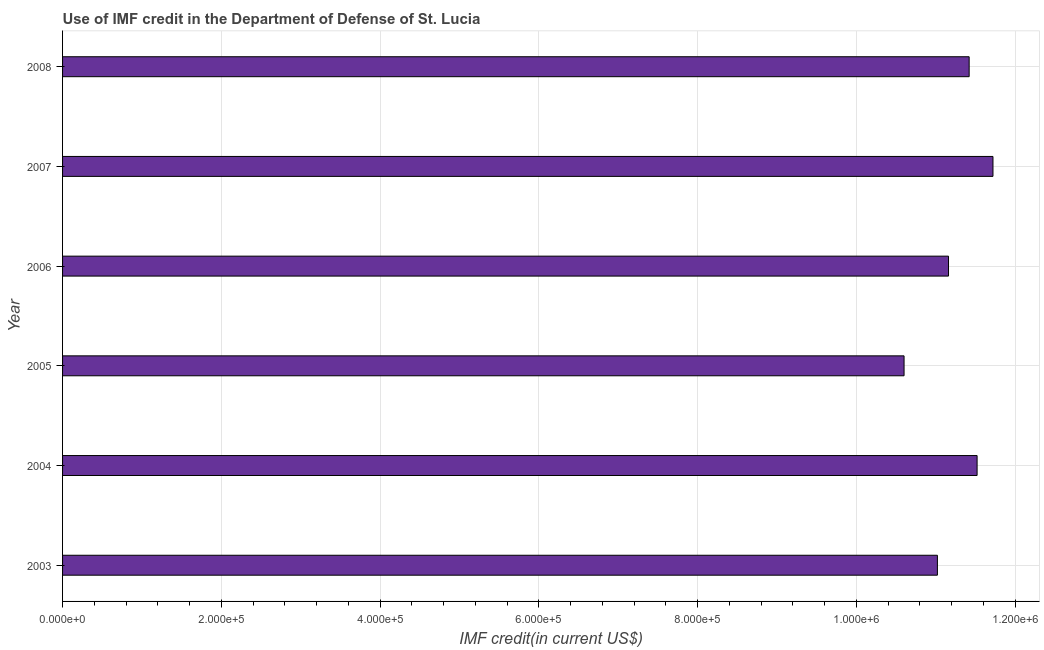What is the title of the graph?
Your response must be concise. Use of IMF credit in the Department of Defense of St. Lucia. What is the label or title of the X-axis?
Keep it short and to the point. IMF credit(in current US$). What is the use of imf credit in dod in 2008?
Offer a terse response. 1.14e+06. Across all years, what is the maximum use of imf credit in dod?
Offer a terse response. 1.17e+06. Across all years, what is the minimum use of imf credit in dod?
Your answer should be compact. 1.06e+06. In which year was the use of imf credit in dod minimum?
Keep it short and to the point. 2005. What is the sum of the use of imf credit in dod?
Keep it short and to the point. 6.74e+06. What is the difference between the use of imf credit in dod in 2003 and 2006?
Ensure brevity in your answer.  -1.40e+04. What is the average use of imf credit in dod per year?
Offer a very short reply. 1.12e+06. What is the median use of imf credit in dod?
Give a very brief answer. 1.13e+06. Do a majority of the years between 2006 and 2005 (inclusive) have use of imf credit in dod greater than 520000 US$?
Ensure brevity in your answer.  No. Is the use of imf credit in dod in 2003 less than that in 2004?
Provide a succinct answer. Yes. What is the difference between the highest and the second highest use of imf credit in dod?
Ensure brevity in your answer.  2.00e+04. Is the sum of the use of imf credit in dod in 2003 and 2007 greater than the maximum use of imf credit in dod across all years?
Provide a succinct answer. Yes. What is the difference between the highest and the lowest use of imf credit in dod?
Your answer should be very brief. 1.12e+05. What is the IMF credit(in current US$) in 2003?
Provide a succinct answer. 1.10e+06. What is the IMF credit(in current US$) in 2004?
Provide a short and direct response. 1.15e+06. What is the IMF credit(in current US$) in 2005?
Ensure brevity in your answer.  1.06e+06. What is the IMF credit(in current US$) in 2006?
Offer a terse response. 1.12e+06. What is the IMF credit(in current US$) in 2007?
Offer a terse response. 1.17e+06. What is the IMF credit(in current US$) in 2008?
Your answer should be compact. 1.14e+06. What is the difference between the IMF credit(in current US$) in 2003 and 2005?
Offer a terse response. 4.20e+04. What is the difference between the IMF credit(in current US$) in 2003 and 2006?
Your answer should be compact. -1.40e+04. What is the difference between the IMF credit(in current US$) in 2003 and 2007?
Provide a succinct answer. -7.00e+04. What is the difference between the IMF credit(in current US$) in 2003 and 2008?
Keep it short and to the point. -4.00e+04. What is the difference between the IMF credit(in current US$) in 2004 and 2005?
Provide a succinct answer. 9.20e+04. What is the difference between the IMF credit(in current US$) in 2004 and 2006?
Your answer should be compact. 3.60e+04. What is the difference between the IMF credit(in current US$) in 2004 and 2008?
Make the answer very short. 10000. What is the difference between the IMF credit(in current US$) in 2005 and 2006?
Ensure brevity in your answer.  -5.60e+04. What is the difference between the IMF credit(in current US$) in 2005 and 2007?
Provide a succinct answer. -1.12e+05. What is the difference between the IMF credit(in current US$) in 2005 and 2008?
Your answer should be compact. -8.20e+04. What is the difference between the IMF credit(in current US$) in 2006 and 2007?
Your response must be concise. -5.60e+04. What is the difference between the IMF credit(in current US$) in 2006 and 2008?
Offer a terse response. -2.60e+04. What is the difference between the IMF credit(in current US$) in 2007 and 2008?
Your answer should be very brief. 3.00e+04. What is the ratio of the IMF credit(in current US$) in 2003 to that in 2004?
Keep it short and to the point. 0.96. What is the ratio of the IMF credit(in current US$) in 2003 to that in 2007?
Make the answer very short. 0.94. What is the ratio of the IMF credit(in current US$) in 2004 to that in 2005?
Offer a terse response. 1.09. What is the ratio of the IMF credit(in current US$) in 2004 to that in 2006?
Your response must be concise. 1.03. What is the ratio of the IMF credit(in current US$) in 2004 to that in 2007?
Make the answer very short. 0.98. What is the ratio of the IMF credit(in current US$) in 2005 to that in 2007?
Your answer should be very brief. 0.9. What is the ratio of the IMF credit(in current US$) in 2005 to that in 2008?
Offer a very short reply. 0.93. What is the ratio of the IMF credit(in current US$) in 2006 to that in 2008?
Offer a terse response. 0.98. 